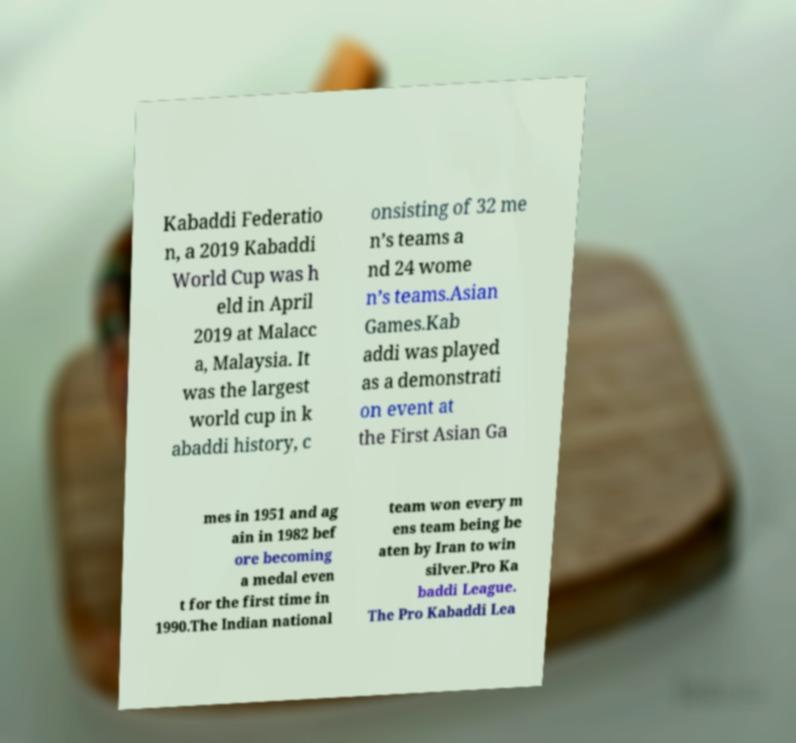Can you accurately transcribe the text from the provided image for me? Kabaddi Federatio n, a 2019 Kabaddi World Cup was h eld in April 2019 at Malacc a, Malaysia. It was the largest world cup in k abaddi history, c onsisting of 32 me n’s teams a nd 24 wome n’s teams.Asian Games.Kab addi was played as a demonstrati on event at the First Asian Ga mes in 1951 and ag ain in 1982 bef ore becoming a medal even t for the first time in 1990.The Indian national team won every m ens team being be aten by Iran to win silver.Pro Ka baddi League. The Pro Kabaddi Lea 